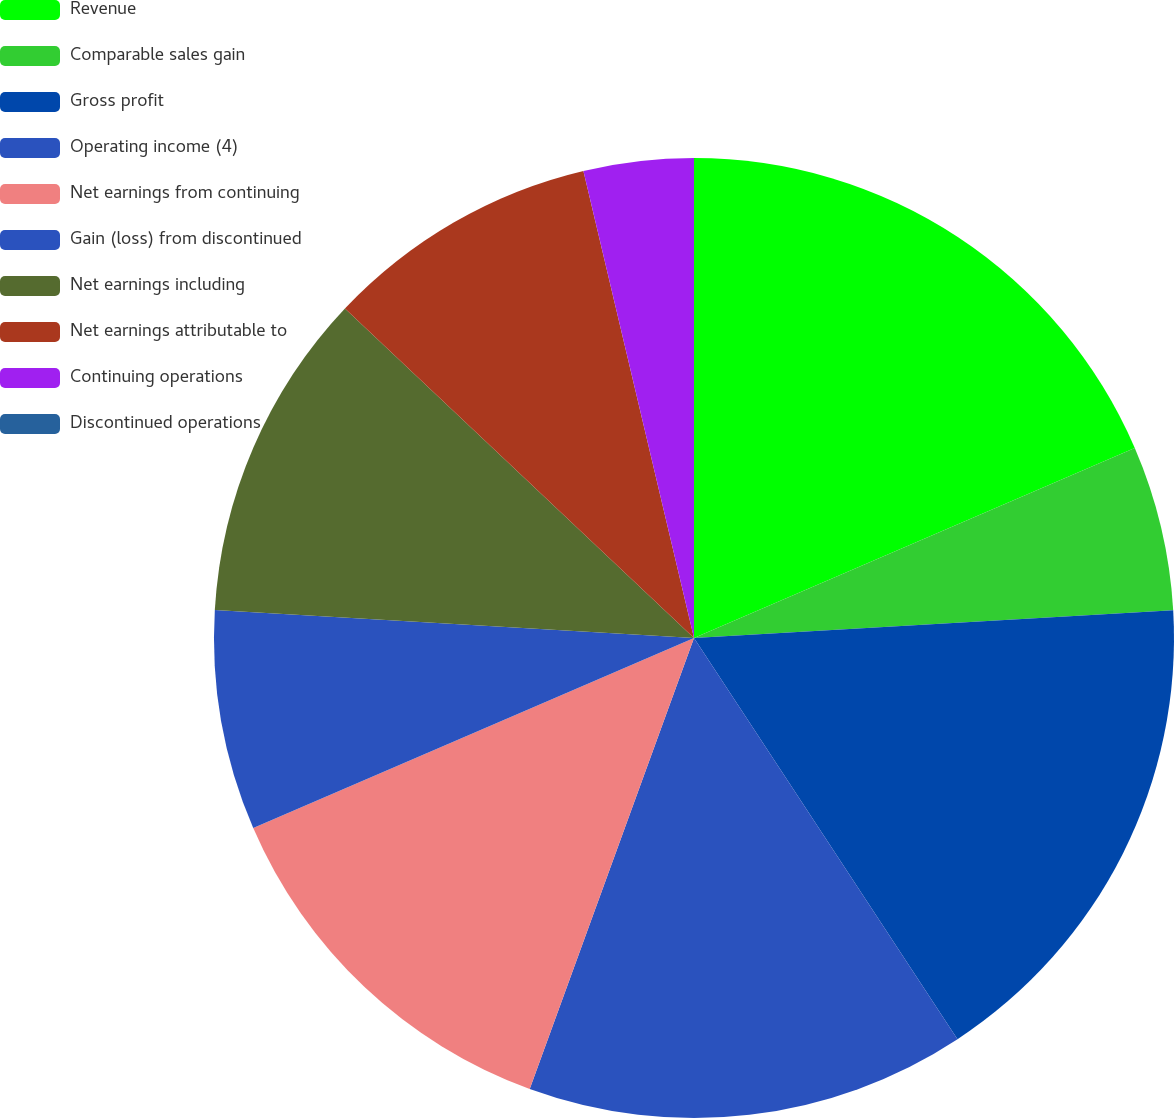Convert chart to OTSL. <chart><loc_0><loc_0><loc_500><loc_500><pie_chart><fcel>Revenue<fcel>Comparable sales gain<fcel>Gross profit<fcel>Operating income (4)<fcel>Net earnings from continuing<fcel>Gain (loss) from discontinued<fcel>Net earnings including<fcel>Net earnings attributable to<fcel>Continuing operations<fcel>Discontinued operations<nl><fcel>18.52%<fcel>5.56%<fcel>16.67%<fcel>14.81%<fcel>12.96%<fcel>7.41%<fcel>11.11%<fcel>9.26%<fcel>3.7%<fcel>0.0%<nl></chart> 